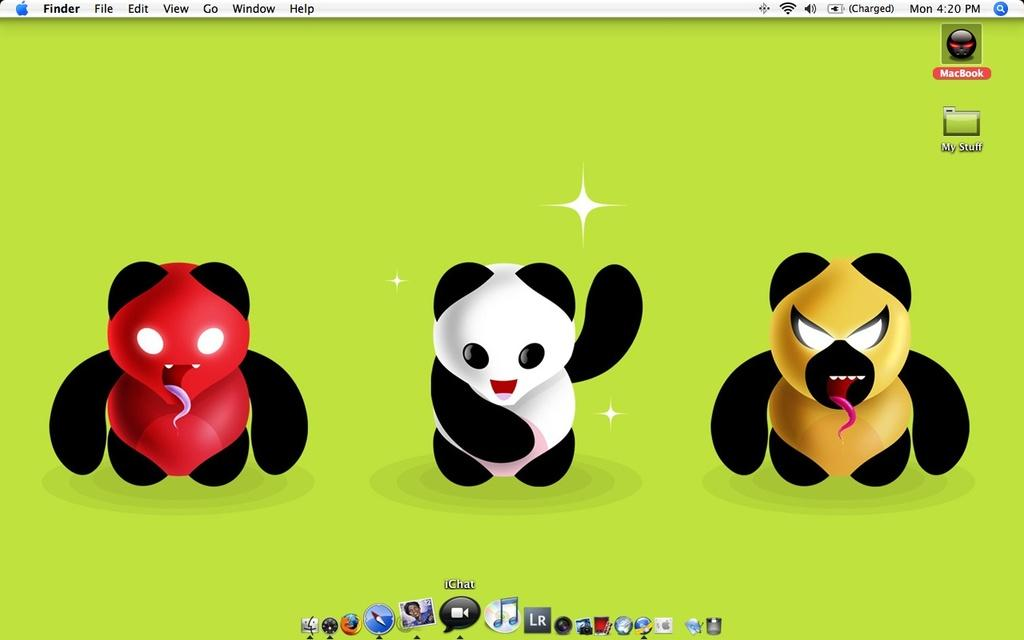What is the main object in the image? There is a computer screen in the image. What is displayed on the computer screen? Cartoons are visible on the computer screen. What type of club is being used to play a game on the computer screen? There is no club present in the image, as it only features a computer screen displaying cartoons. 